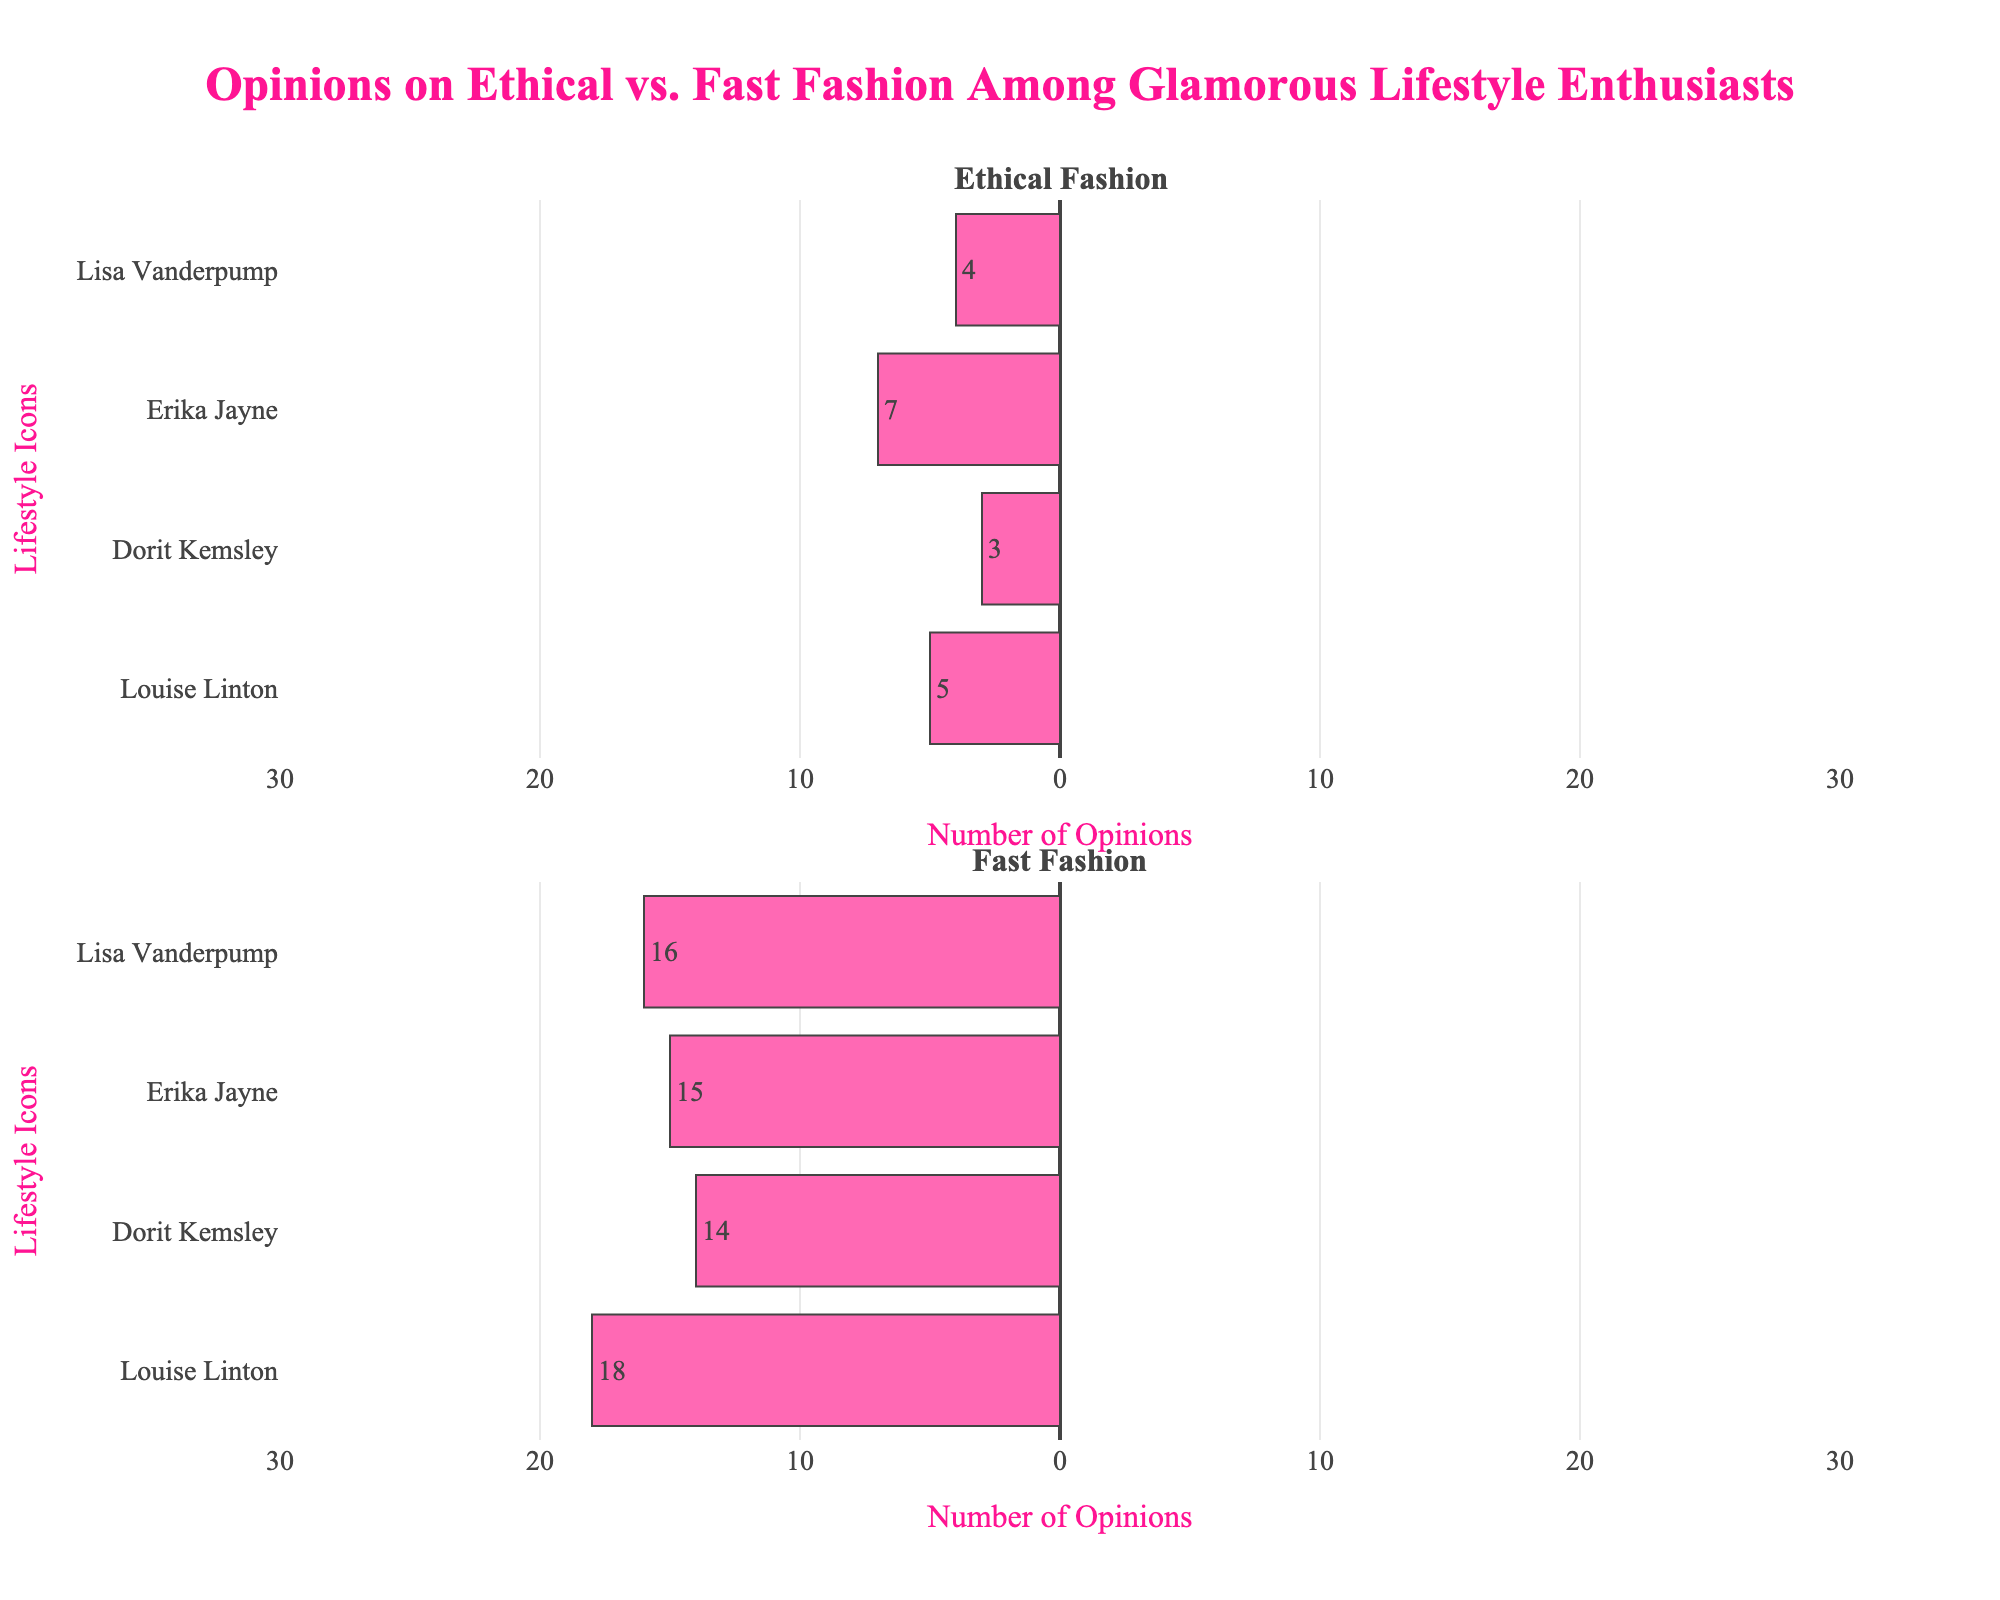What does Lisa Vanderpump think more positively about, ethical fashion or fast fashion? For Lisa Vanderpump, look at the positive and highly positive sections for both ethical fashion and fast fashion. Ethical fashion has higher positive (8) and highly positive (14) sections compared to fast fashion's positive (3) and highly positive (2). Thus, Lisa Vanderpump thinks more positively about ethical fashion.
Answer: Ethical fashion How does Erika Jayne's opinion on fast fashion compare to her opinion on ethical fashion in terms of negativity? Compare the highly negative and negative sections for Erika Jayne in both topics. For fast fashion, Erika Jayne has 7 highly negative and 8 negative opinions (total 15), while for ethical fashion, she has 3 highly negative and 4 negative opinions (total 7). Thus, Erika Jayne is more negative about fast fashion.
Answer: More negative about fast fashion Which housewife has the highest number of neutral opinions on ethical fashion? Compare the neutral sections across all housewives for ethical fashion. Louise Linton, Dorit Kemsley, Erika Jayne, and Lisa Vanderpump have neutral opinions of 5, 4, 5, and 4 respectively. Thus, Erika Jayne and Louise Linton both have the highest (5).
Answer: Erika Jayne and Louise Linton What is the total number of positive opinions on fast fashion among all housewives combined? Sum the positive and highly positive opinions for fast fashion among all housewives: Louise Linton (3+3), Dorit Kemsley (5+7), Erika Jayne (4+4), and Lisa Vanderpump (3+2). The totals are 6, 12, 8, and 5 respectively, summing up to 31.
Answer: 31 How do Dorit Kemsley's neutral opinions compare between ethical fashion and fast fashion? Look at the neutral section for Dorit Kemsley in each topic. For ethical fashion, she has 4 neutral opinions, and for fast fashion, she also has 3 neutral opinions. Ethical fashion has 1 more neutral opinion than fast fashion for her.
Answer: Ethical fashion has 1 more Who has the least negative opinion about fast fashion? Compare the sum of highly negative and negative opinions on fast fashion for all housewives: Louise Linton (10+8), Dorit Kemsley (8+6), Erika Jayne (7+8), and Lisa Vanderpump (9+7). Erika Jayne has the lowest total negative opinions (15).
Answer: Erika Jayne What is the difference in total positive opinions between ethical and fast fashion for Lisa Vanderpump? Calculate the sum of positive and highly positive opinions for Lisa Vanderpump in both topics: Ethical Fashion (8+14=22) and Fast Fashion (3+2=5). The difference is 22 - 5 = 17.
Answer: 17 